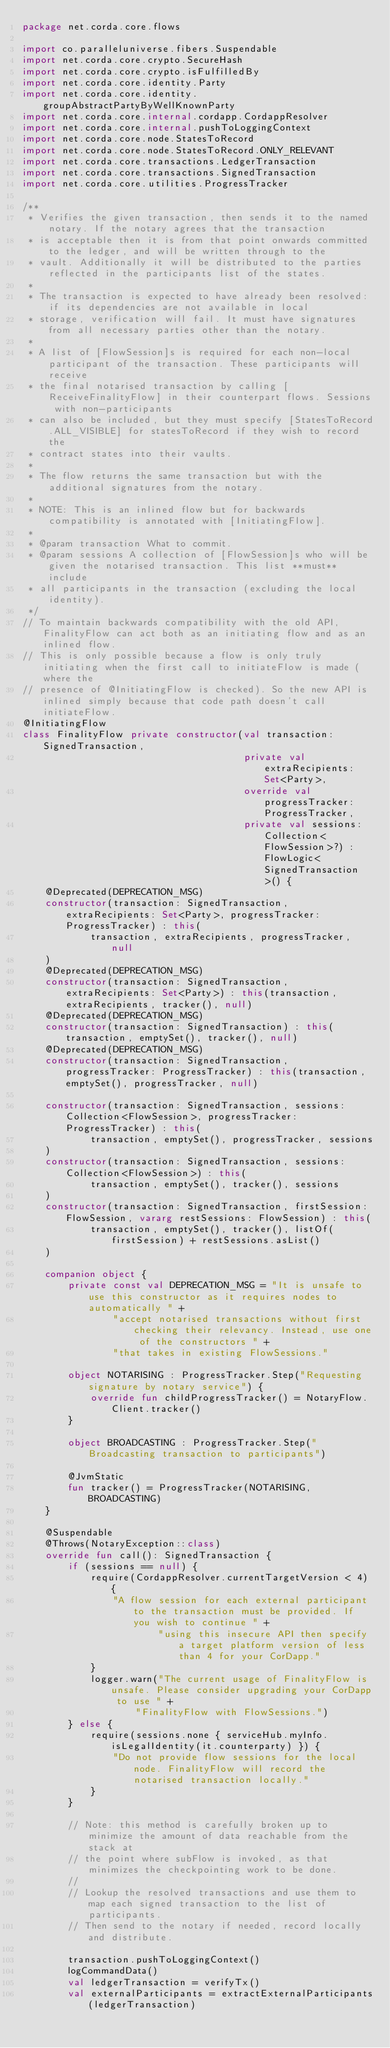<code> <loc_0><loc_0><loc_500><loc_500><_Kotlin_>package net.corda.core.flows

import co.paralleluniverse.fibers.Suspendable
import net.corda.core.crypto.SecureHash
import net.corda.core.crypto.isFulfilledBy
import net.corda.core.identity.Party
import net.corda.core.identity.groupAbstractPartyByWellKnownParty
import net.corda.core.internal.cordapp.CordappResolver
import net.corda.core.internal.pushToLoggingContext
import net.corda.core.node.StatesToRecord
import net.corda.core.node.StatesToRecord.ONLY_RELEVANT
import net.corda.core.transactions.LedgerTransaction
import net.corda.core.transactions.SignedTransaction
import net.corda.core.utilities.ProgressTracker

/**
 * Verifies the given transaction, then sends it to the named notary. If the notary agrees that the transaction
 * is acceptable then it is from that point onwards committed to the ledger, and will be written through to the
 * vault. Additionally it will be distributed to the parties reflected in the participants list of the states.
 *
 * The transaction is expected to have already been resolved: if its dependencies are not available in local
 * storage, verification will fail. It must have signatures from all necessary parties other than the notary.
 *
 * A list of [FlowSession]s is required for each non-local participant of the transaction. These participants will receive
 * the final notarised transaction by calling [ReceiveFinalityFlow] in their counterpart flows. Sessions with non-participants
 * can also be included, but they must specify [StatesToRecord.ALL_VISIBLE] for statesToRecord if they wish to record the
 * contract states into their vaults.
 *
 * The flow returns the same transaction but with the additional signatures from the notary.
 *
 * NOTE: This is an inlined flow but for backwards compatibility is annotated with [InitiatingFlow].
 *
 * @param transaction What to commit.
 * @param sessions A collection of [FlowSession]s who will be given the notarised transaction. This list **must** include
 * all participants in the transaction (excluding the local identity).
 */
// To maintain backwards compatibility with the old API, FinalityFlow can act both as an initiating flow and as an inlined flow.
// This is only possible because a flow is only truly initiating when the first call to initiateFlow is made (where the
// presence of @InitiatingFlow is checked). So the new API is inlined simply because that code path doesn't call initiateFlow.
@InitiatingFlow
class FinalityFlow private constructor(val transaction: SignedTransaction,
                                       private val extraRecipients: Set<Party>,
                                       override val progressTracker: ProgressTracker,
                                       private val sessions: Collection<FlowSession>?) : FlowLogic<SignedTransaction>() {
    @Deprecated(DEPRECATION_MSG)
    constructor(transaction: SignedTransaction, extraRecipients: Set<Party>, progressTracker: ProgressTracker) : this(
            transaction, extraRecipients, progressTracker, null
    )
    @Deprecated(DEPRECATION_MSG)
    constructor(transaction: SignedTransaction, extraRecipients: Set<Party>) : this(transaction, extraRecipients, tracker(), null)
    @Deprecated(DEPRECATION_MSG)
    constructor(transaction: SignedTransaction) : this(transaction, emptySet(), tracker(), null)
    @Deprecated(DEPRECATION_MSG)
    constructor(transaction: SignedTransaction, progressTracker: ProgressTracker) : this(transaction, emptySet(), progressTracker, null)

    constructor(transaction: SignedTransaction, sessions: Collection<FlowSession>, progressTracker: ProgressTracker) : this(
            transaction, emptySet(), progressTracker, sessions
    )
    constructor(transaction: SignedTransaction, sessions: Collection<FlowSession>) : this(
            transaction, emptySet(), tracker(), sessions
    )
    constructor(transaction: SignedTransaction, firstSession: FlowSession, vararg restSessions: FlowSession) : this(
            transaction, emptySet(), tracker(), listOf(firstSession) + restSessions.asList()
    )

    companion object {
        private const val DEPRECATION_MSG = "It is unsafe to use this constructor as it requires nodes to automatically " +
                "accept notarised transactions without first checking their relevancy. Instead, use one of the constructors " +
                "that takes in existing FlowSessions."

        object NOTARISING : ProgressTracker.Step("Requesting signature by notary service") {
            override fun childProgressTracker() = NotaryFlow.Client.tracker()
        }

        object BROADCASTING : ProgressTracker.Step("Broadcasting transaction to participants")

        @JvmStatic
        fun tracker() = ProgressTracker(NOTARISING, BROADCASTING)
    }

    @Suspendable
    @Throws(NotaryException::class)
    override fun call(): SignedTransaction {
        if (sessions == null) {
            require(CordappResolver.currentTargetVersion < 4) {
                "A flow session for each external participant to the transaction must be provided. If you wish to continue " +
                        "using this insecure API then specify a target platform version of less than 4 for your CorDapp."
            }
            logger.warn("The current usage of FinalityFlow is unsafe. Please consider upgrading your CorDapp to use " +
                    "FinalityFlow with FlowSessions.")
        } else {
            require(sessions.none { serviceHub.myInfo.isLegalIdentity(it.counterparty) }) {
                "Do not provide flow sessions for the local node. FinalityFlow will record the notarised transaction locally."
            }
        }

        // Note: this method is carefully broken up to minimize the amount of data reachable from the stack at
        // the point where subFlow is invoked, as that minimizes the checkpointing work to be done.
        //
        // Lookup the resolved transactions and use them to map each signed transaction to the list of participants.
        // Then send to the notary if needed, record locally and distribute.

        transaction.pushToLoggingContext()
        logCommandData()
        val ledgerTransaction = verifyTx()
        val externalParticipants = extractExternalParticipants(ledgerTransaction)
</code> 